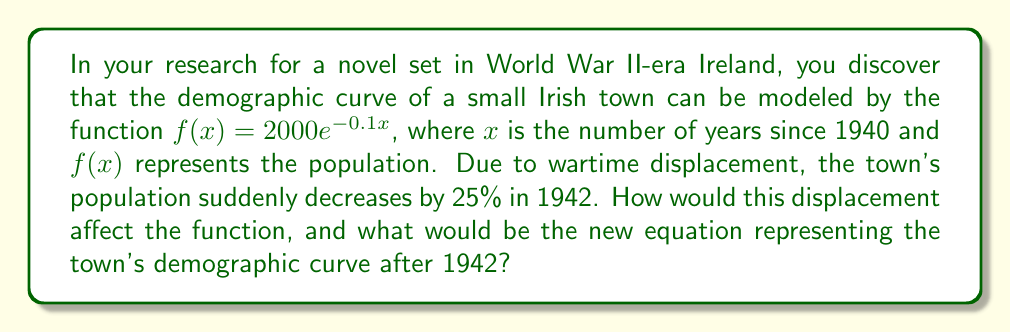Help me with this question. To solve this problem, we need to apply a vertical compression to the original function. Here's how we can approach it step-by-step:

1) The original function is $f(x) = 2000e^{-0.1x}$.

2) A 25% decrease in population means that the new population will be 75% of the original. This can be represented as a vertical compression by a factor of 0.75.

3) To apply a vertical compression, we multiply the entire function by the compression factor:

   $g(x) = 0.75 \cdot f(x)$

4) Substituting the original function:

   $g(x) = 0.75 \cdot (2000e^{-0.1x})$

5) Simplifying:

   $g(x) = 1500e^{-0.1x}$

6) However, this new function represents the population starting from 1940. We need to shift it to start from 1942 (2 years later).

7) To shift the function 2 years to the left, we replace x with (x + 2):

   $g(x) = 1500e^{-0.1(x+2)}$

8) Simplifying the exponent:

   $g(x) = 1500e^{-0.1x-0.2}$

9) We can factor out the $e^{-0.2}$:

   $g(x) = 1500e^{-0.2} \cdot e^{-0.1x}$

10) Calculate $e^{-0.2} \approx 0.8187$

11) Final equation:

    $g(x) = 1228.05e^{-0.1x}$

Where x is now the number of years since 1942.
Answer: The new equation representing the town's demographic curve after 1942 is:

$g(x) = 1228.05e^{-0.1x}$

Where x is the number of years since 1942 and g(x) represents the population. 